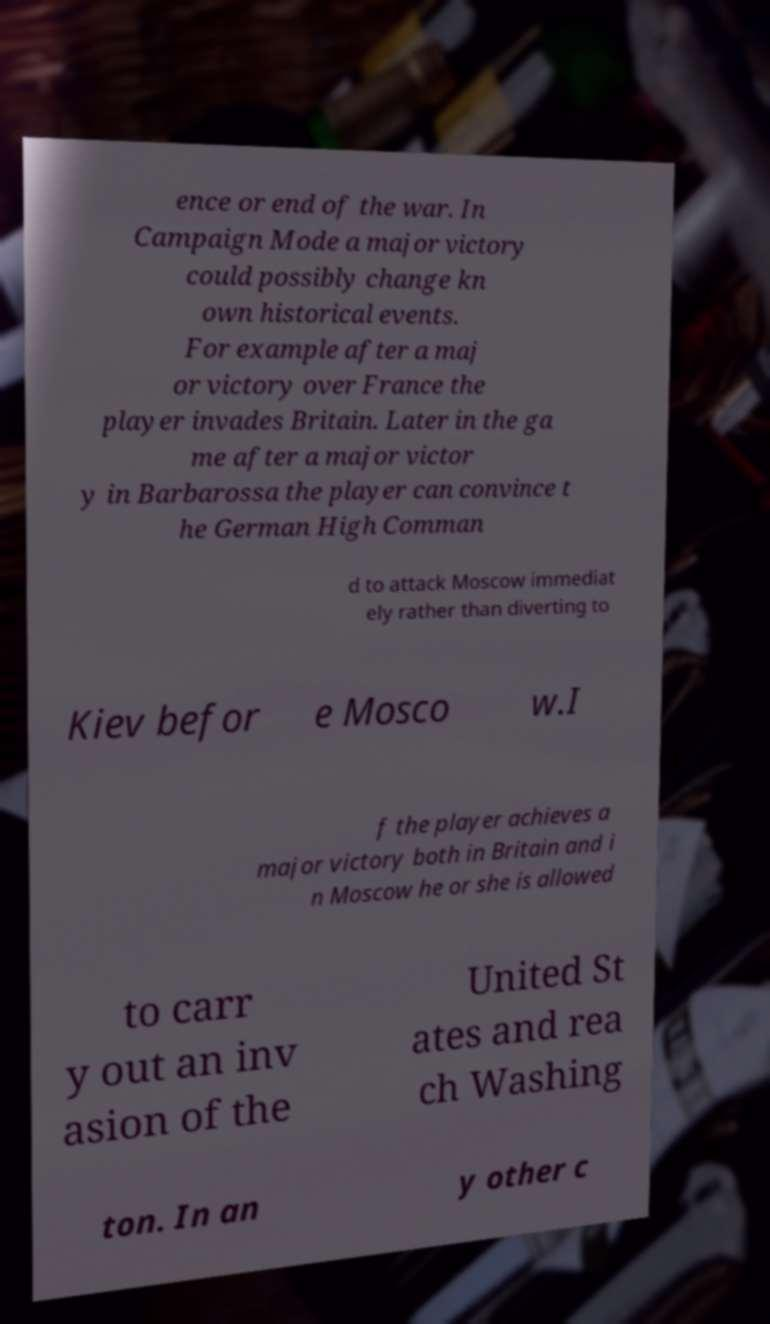There's text embedded in this image that I need extracted. Can you transcribe it verbatim? ence or end of the war. In Campaign Mode a major victory could possibly change kn own historical events. For example after a maj or victory over France the player invades Britain. Later in the ga me after a major victor y in Barbarossa the player can convince t he German High Comman d to attack Moscow immediat ely rather than diverting to Kiev befor e Mosco w.I f the player achieves a major victory both in Britain and i n Moscow he or she is allowed to carr y out an inv asion of the United St ates and rea ch Washing ton. In an y other c 